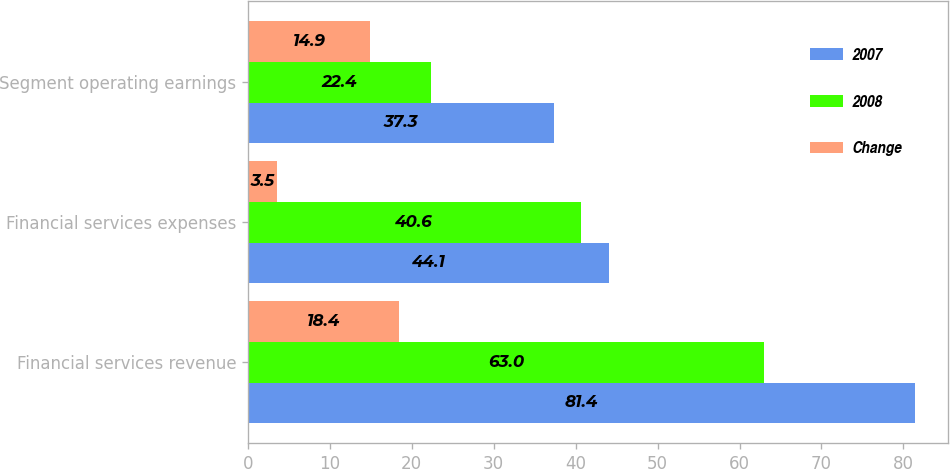<chart> <loc_0><loc_0><loc_500><loc_500><stacked_bar_chart><ecel><fcel>Financial services revenue<fcel>Financial services expenses<fcel>Segment operating earnings<nl><fcel>2007<fcel>81.4<fcel>44.1<fcel>37.3<nl><fcel>2008<fcel>63<fcel>40.6<fcel>22.4<nl><fcel>Change<fcel>18.4<fcel>3.5<fcel>14.9<nl></chart> 